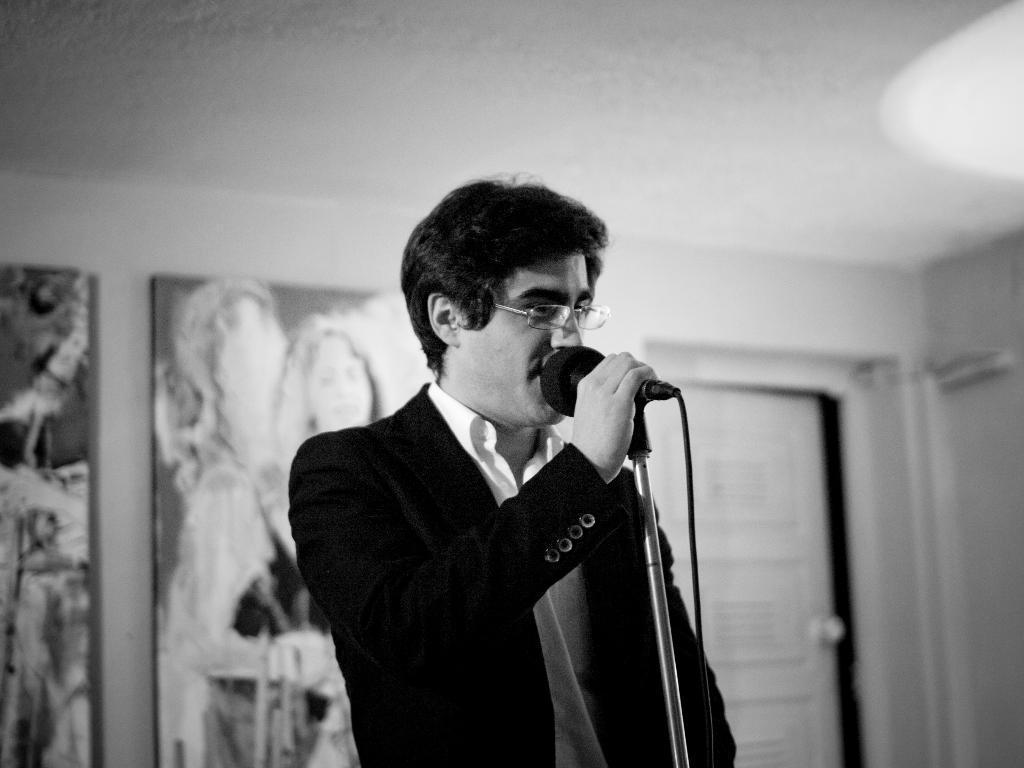Please provide a concise description of this image. In this image, there is an inside view of a building. There is a person at the center of this image standing and holding a mic with his hand. This person is wearing clothes and spectacles. There is wall behind this person. 